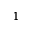<formula> <loc_0><loc_0><loc_500><loc_500>^ { 1 }</formula> 